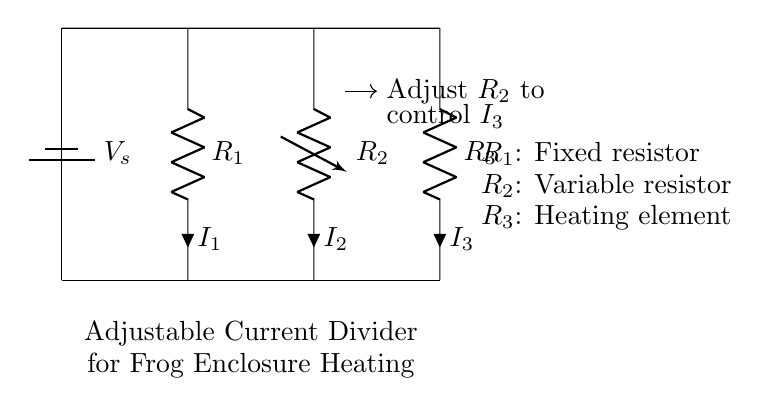What is the voltage source labeled as? The voltage source in the circuit diagram is labeled as V_s, indicating it provides the voltage supply for the circuit.
Answer: V_s What is R_2 in the circuit? R_2 is depicted as a variable resistor, meaning it can be adjusted to control the current flowing through the circuit.
Answer: Variable resistor Which component represents the heating element? The heating element is represented by R_3 in the circuit diagram, which is identified as a resistor.
Answer: R_3 How can you control the current through the heating element? You can control the current through the heating element (I_3) by adjusting the variable resistor (R_2), which influences the division of current in the circuit.
Answer: Adjust R_2 What type of circuit is this? This is an adjustable current divider circuit designed to regulate current to heating elements, as indicated by the arrangement of resistors and the adjustable resistor.
Answer: Current divider What does the current I_1 represent? I_1 represents the current flowing through the fixed resistor R_1 in the circuit, which is part of the current dividing operation.
Answer: Current through R_1 What function does the adjustable current divider serve in this circuit? The function of the adjustable current divider is to provide precise regulation of the heating element's current, making it crucial for maintaining the desired temperature in the frog enclosure.
Answer: Precise regulation of heating 